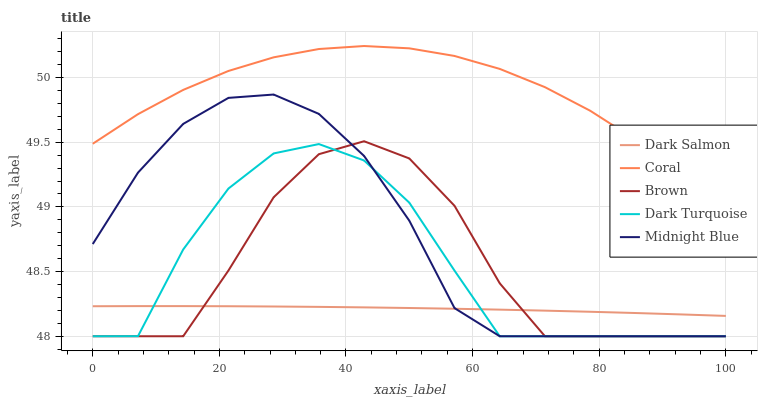Does Dark Salmon have the minimum area under the curve?
Answer yes or no. Yes. Does Coral have the maximum area under the curve?
Answer yes or no. Yes. Does Midnight Blue have the minimum area under the curve?
Answer yes or no. No. Does Midnight Blue have the maximum area under the curve?
Answer yes or no. No. Is Dark Salmon the smoothest?
Answer yes or no. Yes. Is Dark Turquoise the roughest?
Answer yes or no. Yes. Is Coral the smoothest?
Answer yes or no. No. Is Coral the roughest?
Answer yes or no. No. Does Brown have the lowest value?
Answer yes or no. Yes. Does Coral have the lowest value?
Answer yes or no. No. Does Coral have the highest value?
Answer yes or no. Yes. Does Midnight Blue have the highest value?
Answer yes or no. No. Is Brown less than Coral?
Answer yes or no. Yes. Is Coral greater than Brown?
Answer yes or no. Yes. Does Dark Turquoise intersect Dark Salmon?
Answer yes or no. Yes. Is Dark Turquoise less than Dark Salmon?
Answer yes or no. No. Is Dark Turquoise greater than Dark Salmon?
Answer yes or no. No. Does Brown intersect Coral?
Answer yes or no. No. 